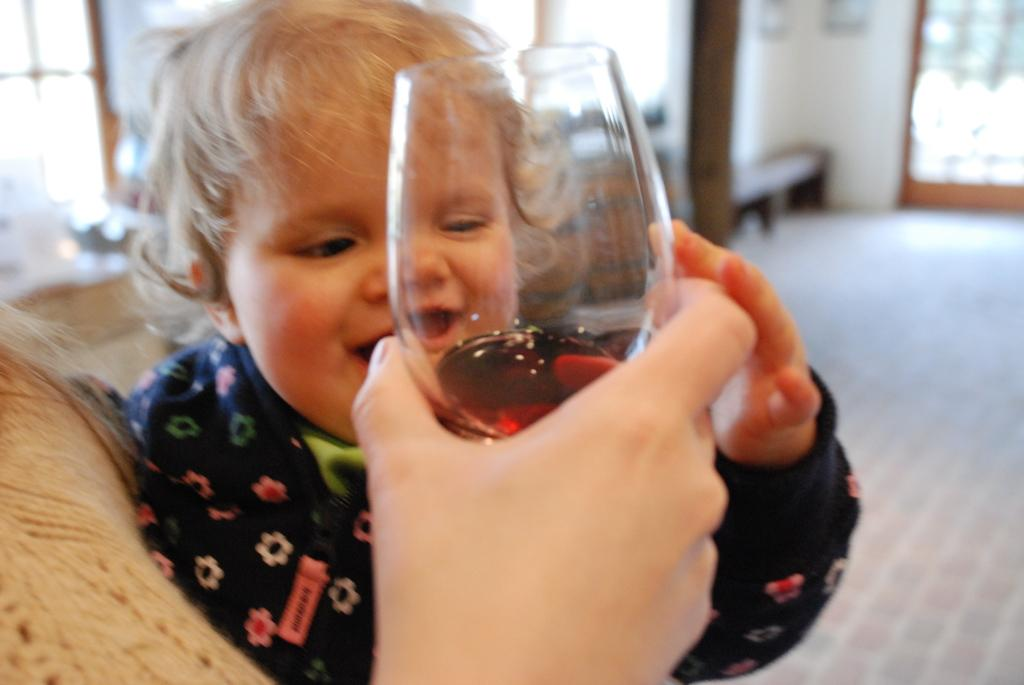What is the main subject in the foreground of the picture? There is a baby in the foreground of the picture. What is another subject in the foreground of the picture? There is a person holding a glass in the foreground of the picture. How would you describe the background of the image? The background of the image is blurred. What architectural features can be seen in the background of the image? There are windows, a pillar, a wall, and a door in the background of the image. How many scarecrows are visible in the image? There are no scarecrows present in the image. What type of clam is being held by the baby in the image? There is no clam present in the image, and the baby is not holding anything. 